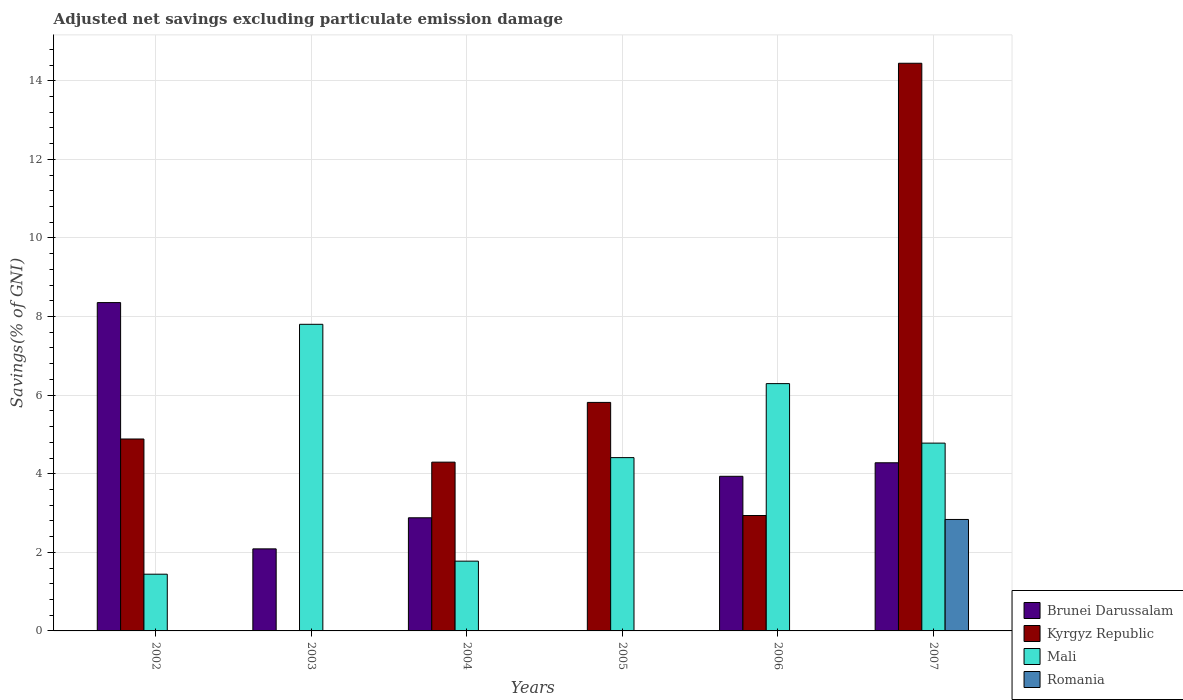In how many cases, is the number of bars for a given year not equal to the number of legend labels?
Your answer should be very brief. 5. What is the adjusted net savings in Kyrgyz Republic in 2006?
Ensure brevity in your answer.  2.94. Across all years, what is the maximum adjusted net savings in Mali?
Give a very brief answer. 7.8. What is the total adjusted net savings in Brunei Darussalam in the graph?
Ensure brevity in your answer.  21.54. What is the difference between the adjusted net savings in Kyrgyz Republic in 2005 and that in 2006?
Provide a succinct answer. 2.88. What is the difference between the adjusted net savings in Mali in 2007 and the adjusted net savings in Brunei Darussalam in 2002?
Provide a succinct answer. -3.58. What is the average adjusted net savings in Brunei Darussalam per year?
Your answer should be very brief. 3.59. In the year 2007, what is the difference between the adjusted net savings in Brunei Darussalam and adjusted net savings in Romania?
Provide a short and direct response. 1.44. In how many years, is the adjusted net savings in Kyrgyz Republic greater than 3.6 %?
Your answer should be compact. 4. What is the ratio of the adjusted net savings in Kyrgyz Republic in 2004 to that in 2005?
Make the answer very short. 0.74. Is the adjusted net savings in Brunei Darussalam in 2002 less than that in 2003?
Your answer should be very brief. No. What is the difference between the highest and the second highest adjusted net savings in Mali?
Your response must be concise. 1.51. What is the difference between the highest and the lowest adjusted net savings in Mali?
Your answer should be very brief. 6.36. Is it the case that in every year, the sum of the adjusted net savings in Kyrgyz Republic and adjusted net savings in Brunei Darussalam is greater than the sum of adjusted net savings in Mali and adjusted net savings in Romania?
Offer a terse response. Yes. Is it the case that in every year, the sum of the adjusted net savings in Brunei Darussalam and adjusted net savings in Romania is greater than the adjusted net savings in Kyrgyz Republic?
Provide a short and direct response. No. Are all the bars in the graph horizontal?
Provide a short and direct response. No. What is the difference between two consecutive major ticks on the Y-axis?
Offer a very short reply. 2. Are the values on the major ticks of Y-axis written in scientific E-notation?
Give a very brief answer. No. What is the title of the graph?
Offer a terse response. Adjusted net savings excluding particulate emission damage. What is the label or title of the X-axis?
Keep it short and to the point. Years. What is the label or title of the Y-axis?
Provide a short and direct response. Savings(% of GNI). What is the Savings(% of GNI) of Brunei Darussalam in 2002?
Your response must be concise. 8.36. What is the Savings(% of GNI) in Kyrgyz Republic in 2002?
Your answer should be very brief. 4.88. What is the Savings(% of GNI) of Mali in 2002?
Offer a terse response. 1.44. What is the Savings(% of GNI) in Romania in 2002?
Offer a very short reply. 0. What is the Savings(% of GNI) of Brunei Darussalam in 2003?
Provide a succinct answer. 2.09. What is the Savings(% of GNI) in Mali in 2003?
Give a very brief answer. 7.8. What is the Savings(% of GNI) of Romania in 2003?
Provide a succinct answer. 0. What is the Savings(% of GNI) of Brunei Darussalam in 2004?
Ensure brevity in your answer.  2.88. What is the Savings(% of GNI) in Kyrgyz Republic in 2004?
Offer a very short reply. 4.29. What is the Savings(% of GNI) in Mali in 2004?
Offer a terse response. 1.78. What is the Savings(% of GNI) of Romania in 2004?
Provide a succinct answer. 0. What is the Savings(% of GNI) in Brunei Darussalam in 2005?
Keep it short and to the point. 0. What is the Savings(% of GNI) of Kyrgyz Republic in 2005?
Provide a short and direct response. 5.82. What is the Savings(% of GNI) in Mali in 2005?
Your answer should be compact. 4.41. What is the Savings(% of GNI) in Romania in 2005?
Give a very brief answer. 0. What is the Savings(% of GNI) in Brunei Darussalam in 2006?
Your answer should be compact. 3.93. What is the Savings(% of GNI) in Kyrgyz Republic in 2006?
Give a very brief answer. 2.94. What is the Savings(% of GNI) of Mali in 2006?
Provide a succinct answer. 6.29. What is the Savings(% of GNI) in Romania in 2006?
Offer a very short reply. 0. What is the Savings(% of GNI) in Brunei Darussalam in 2007?
Your response must be concise. 4.28. What is the Savings(% of GNI) in Kyrgyz Republic in 2007?
Ensure brevity in your answer.  14.45. What is the Savings(% of GNI) in Mali in 2007?
Your response must be concise. 4.78. What is the Savings(% of GNI) in Romania in 2007?
Provide a short and direct response. 2.84. Across all years, what is the maximum Savings(% of GNI) in Brunei Darussalam?
Your response must be concise. 8.36. Across all years, what is the maximum Savings(% of GNI) in Kyrgyz Republic?
Provide a succinct answer. 14.45. Across all years, what is the maximum Savings(% of GNI) in Mali?
Provide a short and direct response. 7.8. Across all years, what is the maximum Savings(% of GNI) in Romania?
Provide a short and direct response. 2.84. Across all years, what is the minimum Savings(% of GNI) in Kyrgyz Republic?
Give a very brief answer. 0. Across all years, what is the minimum Savings(% of GNI) in Mali?
Your answer should be compact. 1.44. Across all years, what is the minimum Savings(% of GNI) in Romania?
Make the answer very short. 0. What is the total Savings(% of GNI) in Brunei Darussalam in the graph?
Your answer should be compact. 21.54. What is the total Savings(% of GNI) in Kyrgyz Republic in the graph?
Ensure brevity in your answer.  32.38. What is the total Savings(% of GNI) in Mali in the graph?
Your response must be concise. 26.51. What is the total Savings(% of GNI) in Romania in the graph?
Your answer should be very brief. 2.84. What is the difference between the Savings(% of GNI) of Brunei Darussalam in 2002 and that in 2003?
Your answer should be compact. 6.27. What is the difference between the Savings(% of GNI) in Mali in 2002 and that in 2003?
Offer a terse response. -6.36. What is the difference between the Savings(% of GNI) of Brunei Darussalam in 2002 and that in 2004?
Provide a succinct answer. 5.48. What is the difference between the Savings(% of GNI) of Kyrgyz Republic in 2002 and that in 2004?
Give a very brief answer. 0.59. What is the difference between the Savings(% of GNI) in Mali in 2002 and that in 2004?
Make the answer very short. -0.33. What is the difference between the Savings(% of GNI) of Kyrgyz Republic in 2002 and that in 2005?
Make the answer very short. -0.93. What is the difference between the Savings(% of GNI) in Mali in 2002 and that in 2005?
Ensure brevity in your answer.  -2.97. What is the difference between the Savings(% of GNI) in Brunei Darussalam in 2002 and that in 2006?
Offer a terse response. 4.42. What is the difference between the Savings(% of GNI) of Kyrgyz Republic in 2002 and that in 2006?
Give a very brief answer. 1.95. What is the difference between the Savings(% of GNI) of Mali in 2002 and that in 2006?
Keep it short and to the point. -4.85. What is the difference between the Savings(% of GNI) of Brunei Darussalam in 2002 and that in 2007?
Make the answer very short. 4.08. What is the difference between the Savings(% of GNI) of Kyrgyz Republic in 2002 and that in 2007?
Ensure brevity in your answer.  -9.56. What is the difference between the Savings(% of GNI) in Mali in 2002 and that in 2007?
Your response must be concise. -3.34. What is the difference between the Savings(% of GNI) of Brunei Darussalam in 2003 and that in 2004?
Keep it short and to the point. -0.79. What is the difference between the Savings(% of GNI) of Mali in 2003 and that in 2004?
Offer a very short reply. 6.03. What is the difference between the Savings(% of GNI) of Mali in 2003 and that in 2005?
Give a very brief answer. 3.39. What is the difference between the Savings(% of GNI) of Brunei Darussalam in 2003 and that in 2006?
Keep it short and to the point. -1.85. What is the difference between the Savings(% of GNI) of Mali in 2003 and that in 2006?
Ensure brevity in your answer.  1.51. What is the difference between the Savings(% of GNI) of Brunei Darussalam in 2003 and that in 2007?
Your response must be concise. -2.19. What is the difference between the Savings(% of GNI) of Mali in 2003 and that in 2007?
Provide a succinct answer. 3.02. What is the difference between the Savings(% of GNI) of Kyrgyz Republic in 2004 and that in 2005?
Provide a short and direct response. -1.52. What is the difference between the Savings(% of GNI) of Mali in 2004 and that in 2005?
Offer a terse response. -2.63. What is the difference between the Savings(% of GNI) in Brunei Darussalam in 2004 and that in 2006?
Ensure brevity in your answer.  -1.06. What is the difference between the Savings(% of GNI) of Kyrgyz Republic in 2004 and that in 2006?
Offer a very short reply. 1.36. What is the difference between the Savings(% of GNI) in Mali in 2004 and that in 2006?
Your answer should be compact. -4.52. What is the difference between the Savings(% of GNI) of Brunei Darussalam in 2004 and that in 2007?
Offer a terse response. -1.4. What is the difference between the Savings(% of GNI) in Kyrgyz Republic in 2004 and that in 2007?
Your answer should be compact. -10.15. What is the difference between the Savings(% of GNI) of Mali in 2004 and that in 2007?
Offer a very short reply. -3. What is the difference between the Savings(% of GNI) of Kyrgyz Republic in 2005 and that in 2006?
Provide a succinct answer. 2.88. What is the difference between the Savings(% of GNI) of Mali in 2005 and that in 2006?
Keep it short and to the point. -1.88. What is the difference between the Savings(% of GNI) of Kyrgyz Republic in 2005 and that in 2007?
Your answer should be very brief. -8.63. What is the difference between the Savings(% of GNI) in Mali in 2005 and that in 2007?
Provide a short and direct response. -0.37. What is the difference between the Savings(% of GNI) of Brunei Darussalam in 2006 and that in 2007?
Offer a very short reply. -0.34. What is the difference between the Savings(% of GNI) in Kyrgyz Republic in 2006 and that in 2007?
Keep it short and to the point. -11.51. What is the difference between the Savings(% of GNI) of Mali in 2006 and that in 2007?
Your answer should be compact. 1.51. What is the difference between the Savings(% of GNI) of Brunei Darussalam in 2002 and the Savings(% of GNI) of Mali in 2003?
Give a very brief answer. 0.55. What is the difference between the Savings(% of GNI) of Kyrgyz Republic in 2002 and the Savings(% of GNI) of Mali in 2003?
Provide a short and direct response. -2.92. What is the difference between the Savings(% of GNI) in Brunei Darussalam in 2002 and the Savings(% of GNI) in Kyrgyz Republic in 2004?
Give a very brief answer. 4.06. What is the difference between the Savings(% of GNI) of Brunei Darussalam in 2002 and the Savings(% of GNI) of Mali in 2004?
Offer a very short reply. 6.58. What is the difference between the Savings(% of GNI) in Kyrgyz Republic in 2002 and the Savings(% of GNI) in Mali in 2004?
Offer a terse response. 3.11. What is the difference between the Savings(% of GNI) of Brunei Darussalam in 2002 and the Savings(% of GNI) of Kyrgyz Republic in 2005?
Ensure brevity in your answer.  2.54. What is the difference between the Savings(% of GNI) in Brunei Darussalam in 2002 and the Savings(% of GNI) in Mali in 2005?
Offer a very short reply. 3.95. What is the difference between the Savings(% of GNI) of Kyrgyz Republic in 2002 and the Savings(% of GNI) of Mali in 2005?
Provide a short and direct response. 0.47. What is the difference between the Savings(% of GNI) of Brunei Darussalam in 2002 and the Savings(% of GNI) of Kyrgyz Republic in 2006?
Your answer should be compact. 5.42. What is the difference between the Savings(% of GNI) in Brunei Darussalam in 2002 and the Savings(% of GNI) in Mali in 2006?
Provide a succinct answer. 2.06. What is the difference between the Savings(% of GNI) in Kyrgyz Republic in 2002 and the Savings(% of GNI) in Mali in 2006?
Make the answer very short. -1.41. What is the difference between the Savings(% of GNI) of Brunei Darussalam in 2002 and the Savings(% of GNI) of Kyrgyz Republic in 2007?
Make the answer very short. -6.09. What is the difference between the Savings(% of GNI) of Brunei Darussalam in 2002 and the Savings(% of GNI) of Mali in 2007?
Give a very brief answer. 3.58. What is the difference between the Savings(% of GNI) of Brunei Darussalam in 2002 and the Savings(% of GNI) of Romania in 2007?
Offer a very short reply. 5.52. What is the difference between the Savings(% of GNI) in Kyrgyz Republic in 2002 and the Savings(% of GNI) in Mali in 2007?
Ensure brevity in your answer.  0.1. What is the difference between the Savings(% of GNI) of Kyrgyz Republic in 2002 and the Savings(% of GNI) of Romania in 2007?
Your answer should be very brief. 2.05. What is the difference between the Savings(% of GNI) in Mali in 2002 and the Savings(% of GNI) in Romania in 2007?
Provide a short and direct response. -1.39. What is the difference between the Savings(% of GNI) of Brunei Darussalam in 2003 and the Savings(% of GNI) of Kyrgyz Republic in 2004?
Your response must be concise. -2.21. What is the difference between the Savings(% of GNI) in Brunei Darussalam in 2003 and the Savings(% of GNI) in Mali in 2004?
Make the answer very short. 0.31. What is the difference between the Savings(% of GNI) in Brunei Darussalam in 2003 and the Savings(% of GNI) in Kyrgyz Republic in 2005?
Provide a succinct answer. -3.73. What is the difference between the Savings(% of GNI) of Brunei Darussalam in 2003 and the Savings(% of GNI) of Mali in 2005?
Make the answer very short. -2.32. What is the difference between the Savings(% of GNI) in Brunei Darussalam in 2003 and the Savings(% of GNI) in Kyrgyz Republic in 2006?
Make the answer very short. -0.85. What is the difference between the Savings(% of GNI) in Brunei Darussalam in 2003 and the Savings(% of GNI) in Mali in 2006?
Provide a short and direct response. -4.21. What is the difference between the Savings(% of GNI) of Brunei Darussalam in 2003 and the Savings(% of GNI) of Kyrgyz Republic in 2007?
Keep it short and to the point. -12.36. What is the difference between the Savings(% of GNI) of Brunei Darussalam in 2003 and the Savings(% of GNI) of Mali in 2007?
Your answer should be very brief. -2.69. What is the difference between the Savings(% of GNI) in Brunei Darussalam in 2003 and the Savings(% of GNI) in Romania in 2007?
Make the answer very short. -0.75. What is the difference between the Savings(% of GNI) in Mali in 2003 and the Savings(% of GNI) in Romania in 2007?
Keep it short and to the point. 4.97. What is the difference between the Savings(% of GNI) of Brunei Darussalam in 2004 and the Savings(% of GNI) of Kyrgyz Republic in 2005?
Offer a very short reply. -2.94. What is the difference between the Savings(% of GNI) in Brunei Darussalam in 2004 and the Savings(% of GNI) in Mali in 2005?
Your response must be concise. -1.53. What is the difference between the Savings(% of GNI) of Kyrgyz Republic in 2004 and the Savings(% of GNI) of Mali in 2005?
Provide a succinct answer. -0.12. What is the difference between the Savings(% of GNI) of Brunei Darussalam in 2004 and the Savings(% of GNI) of Kyrgyz Republic in 2006?
Your answer should be compact. -0.06. What is the difference between the Savings(% of GNI) of Brunei Darussalam in 2004 and the Savings(% of GNI) of Mali in 2006?
Provide a succinct answer. -3.41. What is the difference between the Savings(% of GNI) of Kyrgyz Republic in 2004 and the Savings(% of GNI) of Mali in 2006?
Your answer should be very brief. -2. What is the difference between the Savings(% of GNI) of Brunei Darussalam in 2004 and the Savings(% of GNI) of Kyrgyz Republic in 2007?
Ensure brevity in your answer.  -11.57. What is the difference between the Savings(% of GNI) of Brunei Darussalam in 2004 and the Savings(% of GNI) of Mali in 2007?
Your answer should be very brief. -1.9. What is the difference between the Savings(% of GNI) of Brunei Darussalam in 2004 and the Savings(% of GNI) of Romania in 2007?
Provide a succinct answer. 0.04. What is the difference between the Savings(% of GNI) of Kyrgyz Republic in 2004 and the Savings(% of GNI) of Mali in 2007?
Your answer should be compact. -0.48. What is the difference between the Savings(% of GNI) of Kyrgyz Republic in 2004 and the Savings(% of GNI) of Romania in 2007?
Ensure brevity in your answer.  1.46. What is the difference between the Savings(% of GNI) in Mali in 2004 and the Savings(% of GNI) in Romania in 2007?
Provide a succinct answer. -1.06. What is the difference between the Savings(% of GNI) of Kyrgyz Republic in 2005 and the Savings(% of GNI) of Mali in 2006?
Ensure brevity in your answer.  -0.48. What is the difference between the Savings(% of GNI) in Kyrgyz Republic in 2005 and the Savings(% of GNI) in Mali in 2007?
Keep it short and to the point. 1.04. What is the difference between the Savings(% of GNI) of Kyrgyz Republic in 2005 and the Savings(% of GNI) of Romania in 2007?
Give a very brief answer. 2.98. What is the difference between the Savings(% of GNI) of Mali in 2005 and the Savings(% of GNI) of Romania in 2007?
Provide a short and direct response. 1.57. What is the difference between the Savings(% of GNI) of Brunei Darussalam in 2006 and the Savings(% of GNI) of Kyrgyz Republic in 2007?
Keep it short and to the point. -10.51. What is the difference between the Savings(% of GNI) in Brunei Darussalam in 2006 and the Savings(% of GNI) in Mali in 2007?
Provide a short and direct response. -0.84. What is the difference between the Savings(% of GNI) of Brunei Darussalam in 2006 and the Savings(% of GNI) of Romania in 2007?
Provide a short and direct response. 1.1. What is the difference between the Savings(% of GNI) of Kyrgyz Republic in 2006 and the Savings(% of GNI) of Mali in 2007?
Provide a succinct answer. -1.84. What is the difference between the Savings(% of GNI) in Kyrgyz Republic in 2006 and the Savings(% of GNI) in Romania in 2007?
Offer a terse response. 0.1. What is the difference between the Savings(% of GNI) of Mali in 2006 and the Savings(% of GNI) of Romania in 2007?
Make the answer very short. 3.46. What is the average Savings(% of GNI) in Brunei Darussalam per year?
Your answer should be compact. 3.59. What is the average Savings(% of GNI) of Kyrgyz Republic per year?
Offer a terse response. 5.4. What is the average Savings(% of GNI) of Mali per year?
Provide a succinct answer. 4.42. What is the average Savings(% of GNI) of Romania per year?
Offer a very short reply. 0.47. In the year 2002, what is the difference between the Savings(% of GNI) of Brunei Darussalam and Savings(% of GNI) of Kyrgyz Republic?
Keep it short and to the point. 3.47. In the year 2002, what is the difference between the Savings(% of GNI) of Brunei Darussalam and Savings(% of GNI) of Mali?
Ensure brevity in your answer.  6.91. In the year 2002, what is the difference between the Savings(% of GNI) in Kyrgyz Republic and Savings(% of GNI) in Mali?
Give a very brief answer. 3.44. In the year 2003, what is the difference between the Savings(% of GNI) of Brunei Darussalam and Savings(% of GNI) of Mali?
Your answer should be very brief. -5.71. In the year 2004, what is the difference between the Savings(% of GNI) in Brunei Darussalam and Savings(% of GNI) in Kyrgyz Republic?
Give a very brief answer. -1.42. In the year 2004, what is the difference between the Savings(% of GNI) in Brunei Darussalam and Savings(% of GNI) in Mali?
Offer a terse response. 1.1. In the year 2004, what is the difference between the Savings(% of GNI) of Kyrgyz Republic and Savings(% of GNI) of Mali?
Your response must be concise. 2.52. In the year 2005, what is the difference between the Savings(% of GNI) in Kyrgyz Republic and Savings(% of GNI) in Mali?
Ensure brevity in your answer.  1.4. In the year 2006, what is the difference between the Savings(% of GNI) of Brunei Darussalam and Savings(% of GNI) of Mali?
Provide a succinct answer. -2.36. In the year 2006, what is the difference between the Savings(% of GNI) in Kyrgyz Republic and Savings(% of GNI) in Mali?
Provide a succinct answer. -3.36. In the year 2007, what is the difference between the Savings(% of GNI) of Brunei Darussalam and Savings(% of GNI) of Kyrgyz Republic?
Offer a terse response. -10.17. In the year 2007, what is the difference between the Savings(% of GNI) of Brunei Darussalam and Savings(% of GNI) of Mali?
Your response must be concise. -0.5. In the year 2007, what is the difference between the Savings(% of GNI) of Brunei Darussalam and Savings(% of GNI) of Romania?
Keep it short and to the point. 1.44. In the year 2007, what is the difference between the Savings(% of GNI) in Kyrgyz Republic and Savings(% of GNI) in Mali?
Offer a terse response. 9.67. In the year 2007, what is the difference between the Savings(% of GNI) in Kyrgyz Republic and Savings(% of GNI) in Romania?
Offer a terse response. 11.61. In the year 2007, what is the difference between the Savings(% of GNI) in Mali and Savings(% of GNI) in Romania?
Your answer should be compact. 1.94. What is the ratio of the Savings(% of GNI) of Brunei Darussalam in 2002 to that in 2003?
Ensure brevity in your answer.  4. What is the ratio of the Savings(% of GNI) of Mali in 2002 to that in 2003?
Offer a very short reply. 0.18. What is the ratio of the Savings(% of GNI) in Brunei Darussalam in 2002 to that in 2004?
Give a very brief answer. 2.9. What is the ratio of the Savings(% of GNI) in Kyrgyz Republic in 2002 to that in 2004?
Provide a succinct answer. 1.14. What is the ratio of the Savings(% of GNI) of Mali in 2002 to that in 2004?
Provide a short and direct response. 0.81. What is the ratio of the Savings(% of GNI) of Kyrgyz Republic in 2002 to that in 2005?
Offer a terse response. 0.84. What is the ratio of the Savings(% of GNI) in Mali in 2002 to that in 2005?
Make the answer very short. 0.33. What is the ratio of the Savings(% of GNI) in Brunei Darussalam in 2002 to that in 2006?
Make the answer very short. 2.12. What is the ratio of the Savings(% of GNI) of Kyrgyz Republic in 2002 to that in 2006?
Provide a succinct answer. 1.66. What is the ratio of the Savings(% of GNI) of Mali in 2002 to that in 2006?
Provide a short and direct response. 0.23. What is the ratio of the Savings(% of GNI) of Brunei Darussalam in 2002 to that in 2007?
Make the answer very short. 1.95. What is the ratio of the Savings(% of GNI) in Kyrgyz Republic in 2002 to that in 2007?
Ensure brevity in your answer.  0.34. What is the ratio of the Savings(% of GNI) of Mali in 2002 to that in 2007?
Provide a succinct answer. 0.3. What is the ratio of the Savings(% of GNI) in Brunei Darussalam in 2003 to that in 2004?
Give a very brief answer. 0.73. What is the ratio of the Savings(% of GNI) of Mali in 2003 to that in 2004?
Give a very brief answer. 4.39. What is the ratio of the Savings(% of GNI) of Mali in 2003 to that in 2005?
Keep it short and to the point. 1.77. What is the ratio of the Savings(% of GNI) in Brunei Darussalam in 2003 to that in 2006?
Offer a terse response. 0.53. What is the ratio of the Savings(% of GNI) in Mali in 2003 to that in 2006?
Your answer should be compact. 1.24. What is the ratio of the Savings(% of GNI) in Brunei Darussalam in 2003 to that in 2007?
Your response must be concise. 0.49. What is the ratio of the Savings(% of GNI) of Mali in 2003 to that in 2007?
Your answer should be compact. 1.63. What is the ratio of the Savings(% of GNI) of Kyrgyz Republic in 2004 to that in 2005?
Your answer should be very brief. 0.74. What is the ratio of the Savings(% of GNI) in Mali in 2004 to that in 2005?
Your answer should be very brief. 0.4. What is the ratio of the Savings(% of GNI) in Brunei Darussalam in 2004 to that in 2006?
Make the answer very short. 0.73. What is the ratio of the Savings(% of GNI) in Kyrgyz Republic in 2004 to that in 2006?
Give a very brief answer. 1.46. What is the ratio of the Savings(% of GNI) in Mali in 2004 to that in 2006?
Offer a terse response. 0.28. What is the ratio of the Savings(% of GNI) of Brunei Darussalam in 2004 to that in 2007?
Your answer should be very brief. 0.67. What is the ratio of the Savings(% of GNI) of Kyrgyz Republic in 2004 to that in 2007?
Make the answer very short. 0.3. What is the ratio of the Savings(% of GNI) in Mali in 2004 to that in 2007?
Make the answer very short. 0.37. What is the ratio of the Savings(% of GNI) in Kyrgyz Republic in 2005 to that in 2006?
Give a very brief answer. 1.98. What is the ratio of the Savings(% of GNI) of Mali in 2005 to that in 2006?
Give a very brief answer. 0.7. What is the ratio of the Savings(% of GNI) in Kyrgyz Republic in 2005 to that in 2007?
Make the answer very short. 0.4. What is the ratio of the Savings(% of GNI) in Mali in 2005 to that in 2007?
Give a very brief answer. 0.92. What is the ratio of the Savings(% of GNI) of Brunei Darussalam in 2006 to that in 2007?
Make the answer very short. 0.92. What is the ratio of the Savings(% of GNI) in Kyrgyz Republic in 2006 to that in 2007?
Make the answer very short. 0.2. What is the ratio of the Savings(% of GNI) in Mali in 2006 to that in 2007?
Provide a succinct answer. 1.32. What is the difference between the highest and the second highest Savings(% of GNI) of Brunei Darussalam?
Keep it short and to the point. 4.08. What is the difference between the highest and the second highest Savings(% of GNI) of Kyrgyz Republic?
Ensure brevity in your answer.  8.63. What is the difference between the highest and the second highest Savings(% of GNI) of Mali?
Make the answer very short. 1.51. What is the difference between the highest and the lowest Savings(% of GNI) in Brunei Darussalam?
Keep it short and to the point. 8.36. What is the difference between the highest and the lowest Savings(% of GNI) of Kyrgyz Republic?
Keep it short and to the point. 14.45. What is the difference between the highest and the lowest Savings(% of GNI) in Mali?
Your answer should be compact. 6.36. What is the difference between the highest and the lowest Savings(% of GNI) in Romania?
Your answer should be compact. 2.84. 